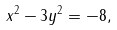<formula> <loc_0><loc_0><loc_500><loc_500>x ^ { 2 } - 3 y ^ { 2 } = - 8 ,</formula> 